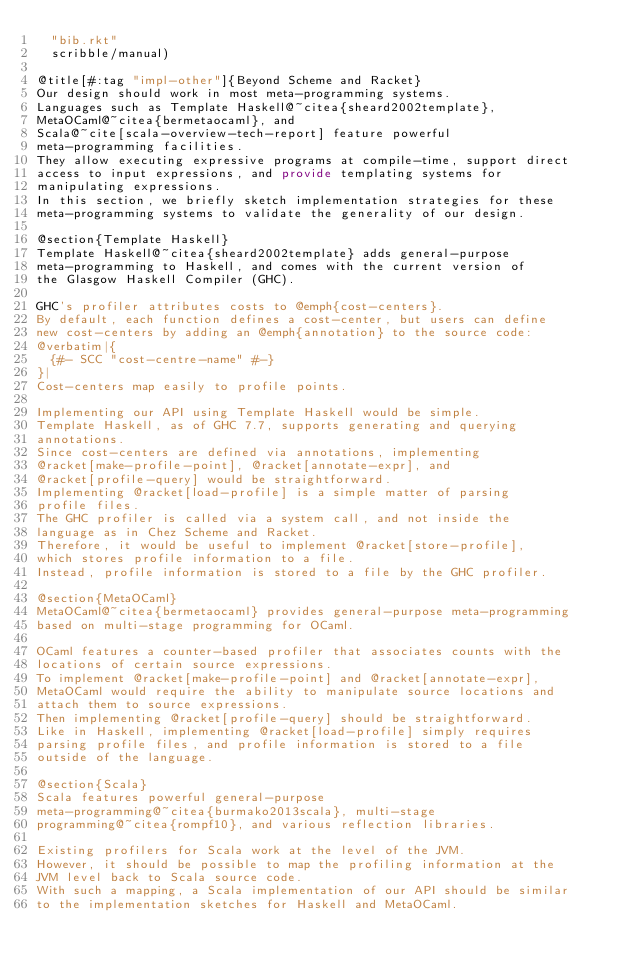Convert code to text. <code><loc_0><loc_0><loc_500><loc_500><_Racket_>  "bib.rkt"
  scribble/manual)

@title[#:tag "impl-other"]{Beyond Scheme and Racket}
Our design should work in most meta-programming systems.
Languages such as Template Haskell@~citea{sheard2002template},
MetaOCaml@~citea{bermetaocaml}, and
Scala@~cite[scala-overview-tech-report] feature powerful
meta-programming facilities.
They allow executing expressive programs at compile-time, support direct
access to input expressions, and provide templating systems for
manipulating expressions.
In this section, we briefly sketch implementation strategies for these
meta-programming systems to validate the generality of our design.

@section{Template Haskell}
Template Haskell@~citea{sheard2002template} adds general-purpose
meta-programming to Haskell, and comes with the current version of
the Glasgow Haskell Compiler (GHC).

GHC's profiler attributes costs to @emph{cost-centers}.
By default, each function defines a cost-center, but users can define
new cost-centers by adding an @emph{annotation} to the source code:
@verbatim|{
  {#- SCC "cost-centre-name" #-}
}|
Cost-centers map easily to profile points.

Implementing our API using Template Haskell would be simple.
Template Haskell, as of GHC 7.7, supports generating and querying
annotations.
Since cost-centers are defined via annotations, implementing
@racket[make-profile-point], @racket[annotate-expr], and
@racket[profile-query] would be straightforward.
Implementing @racket[load-profile] is a simple matter of parsing
profile files.
The GHC profiler is called via a system call, and not inside the
language as in Chez Scheme and Racket.
Therefore, it would be useful to implement @racket[store-profile],
which stores profile information to a file.
Instead, profile information is stored to a file by the GHC profiler.

@section{MetaOCaml}
MetaOCaml@~citea{bermetaocaml} provides general-purpose meta-programming
based on multi-stage programming for OCaml.

OCaml features a counter-based profiler that associates counts with the
locations of certain source expressions.
To implement @racket[make-profile-point] and @racket[annotate-expr],
MetaOCaml would require the ability to manipulate source locations and
attach them to source expressions.
Then implementing @racket[profile-query] should be straightforward.
Like in Haskell, implementing @racket[load-profile] simply requires
parsing profile files, and profile information is stored to a file
outside of the language.

@section{Scala}
Scala features powerful general-purpose
meta-programming@~citea{burmako2013scala}, multi-stage
programming@~citea{rompf10}, and various reflection libraries.

Existing profilers for Scala work at the level of the JVM.
However, it should be possible to map the profiling information at the
JVM level back to Scala source code.
With such a mapping, a Scala implementation of our API should be similar
to the implementation sketches for Haskell and MetaOCaml.
</code> 